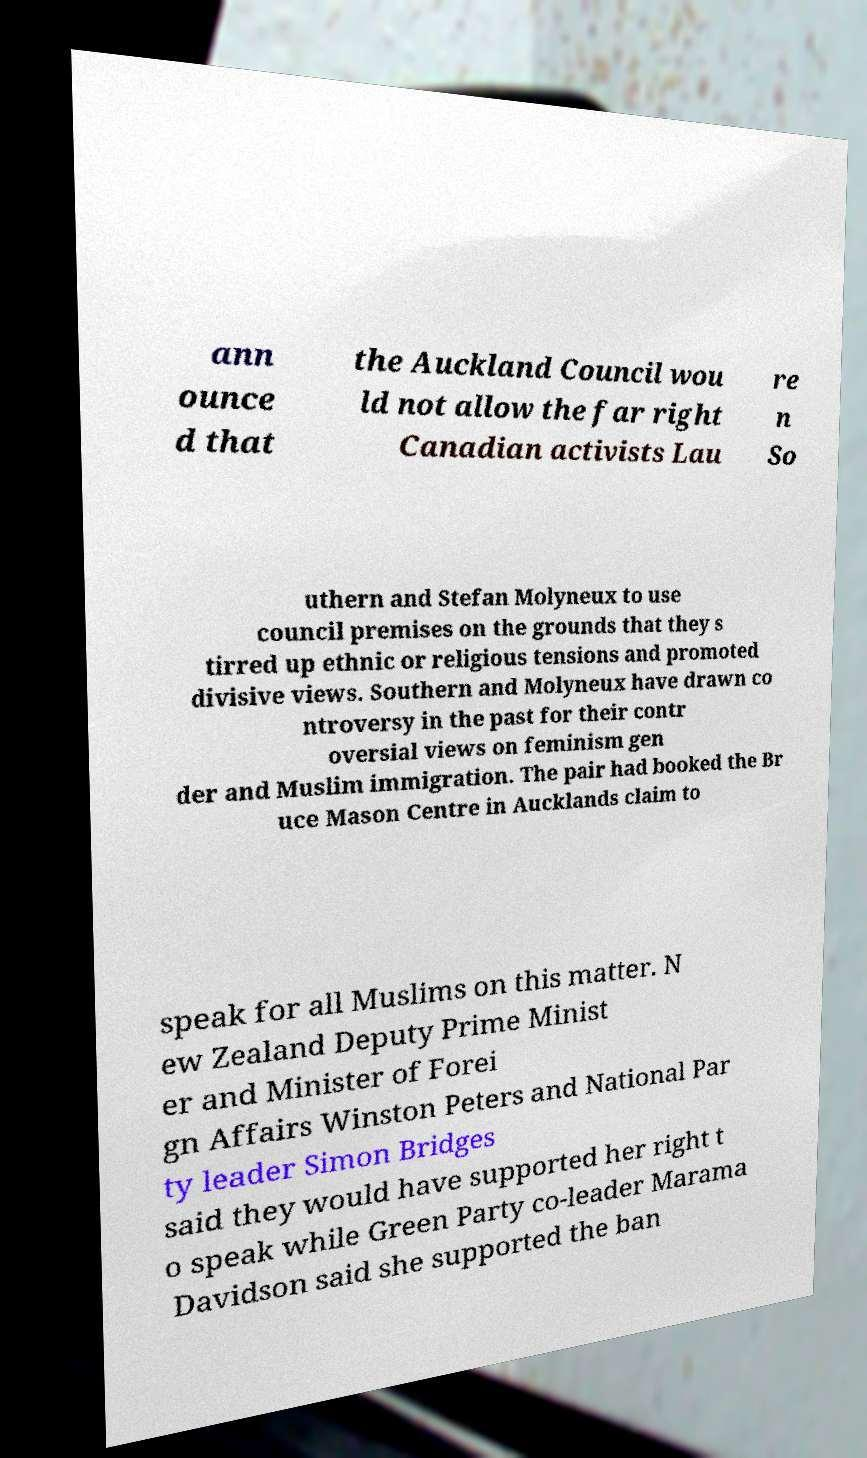I need the written content from this picture converted into text. Can you do that? ann ounce d that the Auckland Council wou ld not allow the far right Canadian activists Lau re n So uthern and Stefan Molyneux to use council premises on the grounds that they s tirred up ethnic or religious tensions and promoted divisive views. Southern and Molyneux have drawn co ntroversy in the past for their contr oversial views on feminism gen der and Muslim immigration. The pair had booked the Br uce Mason Centre in Aucklands claim to speak for all Muslims on this matter. N ew Zealand Deputy Prime Minist er and Minister of Forei gn Affairs Winston Peters and National Par ty leader Simon Bridges said they would have supported her right t o speak while Green Party co-leader Marama Davidson said she supported the ban 